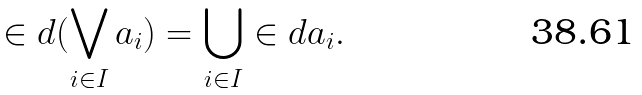Convert formula to latex. <formula><loc_0><loc_0><loc_500><loc_500>\in d ( \bigvee _ { i \in I } a _ { i } ) = \bigcup _ { i \in I } \in d a _ { i } .</formula> 